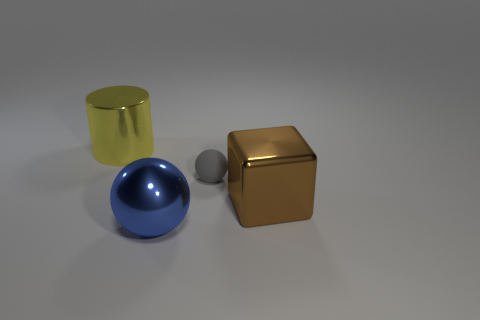How many yellow objects have the same material as the large brown block? There appears to be one yellow cylinder that seems to share the same glossy material quality as the large brown cube. 